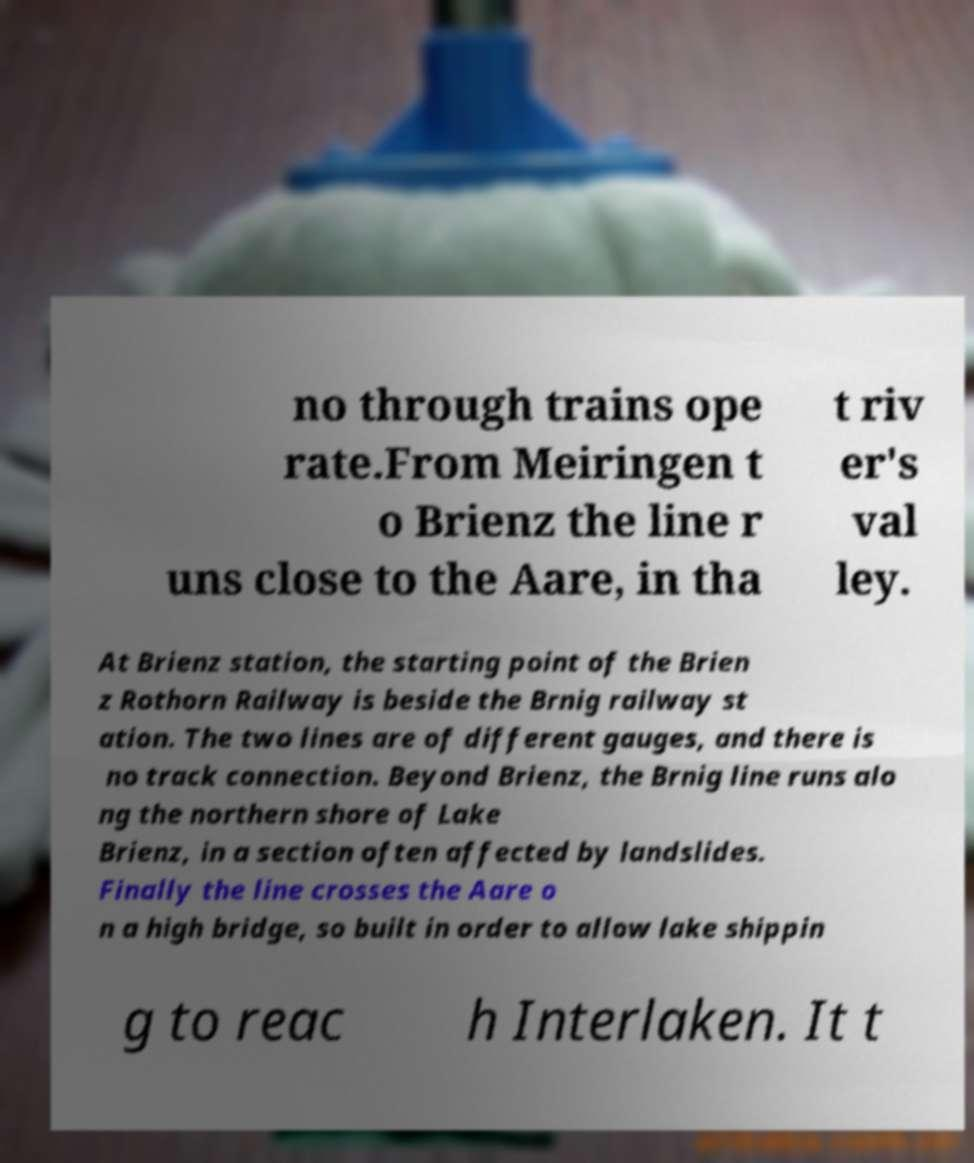Could you extract and type out the text from this image? no through trains ope rate.From Meiringen t o Brienz the line r uns close to the Aare, in tha t riv er's val ley. At Brienz station, the starting point of the Brien z Rothorn Railway is beside the Brnig railway st ation. The two lines are of different gauges, and there is no track connection. Beyond Brienz, the Brnig line runs alo ng the northern shore of Lake Brienz, in a section often affected by landslides. Finally the line crosses the Aare o n a high bridge, so built in order to allow lake shippin g to reac h Interlaken. It t 